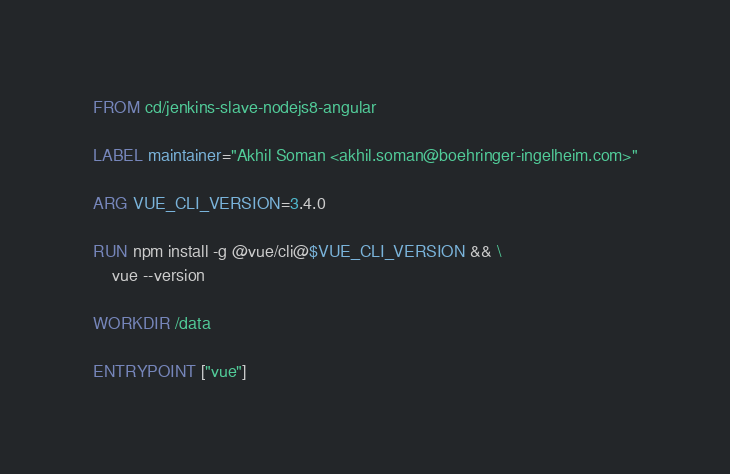Convert code to text. <code><loc_0><loc_0><loc_500><loc_500><_Dockerfile_>FROM cd/jenkins-slave-nodejs8-angular

LABEL maintainer="Akhil Soman <akhil.soman@boehringer-ingelheim.com>"

ARG VUE_CLI_VERSION=3.4.0

RUN npm install -g @vue/cli@$VUE_CLI_VERSION && \
    vue --version

WORKDIR /data

ENTRYPOINT ["vue"]

</code> 